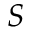<formula> <loc_0><loc_0><loc_500><loc_500>S</formula> 